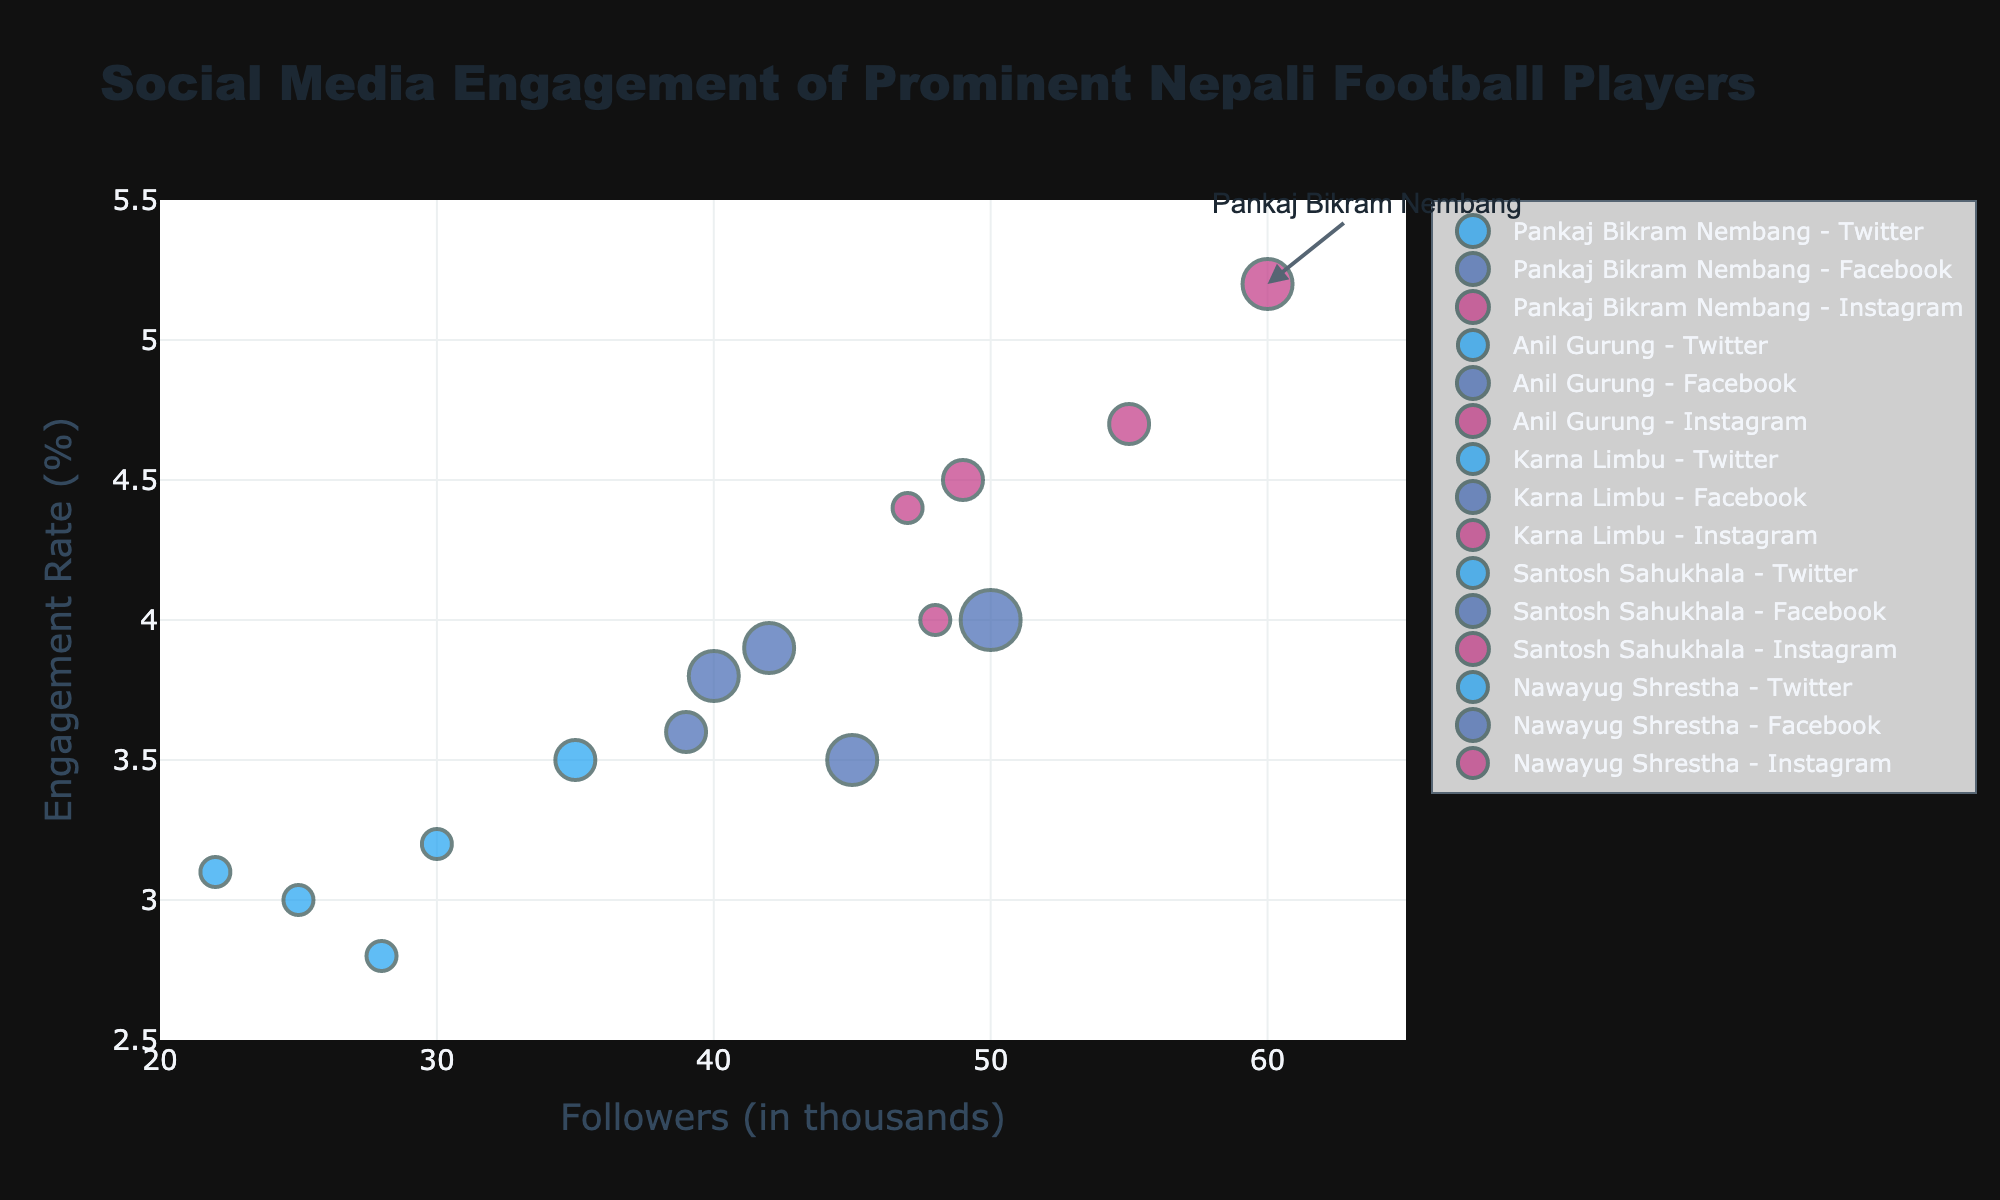what is the title of the chart? The title of the chart is displayed at the top center of the figure in a larger font size, making it easy to identify the central theme of the chart.
Answer: Social Media Engagement of Prominent Nepali Football Players How many players are shown in the bubble chart? The bubble chart includes distinct bubbles representing individual players across platforms. Each player's data can be identified by examining the hover information or legend. There are five players: Pankaj Bikram Nembang, Anil Gurung, Karna Limbu, Santosh Sahukhala, and Nawayug Shrestha.
Answer: Five Who has the highest engagement rate on Instagram? By examining the Y-axis values for Instagram's colored bubbles on the chart, one can identify the highest engagement rate. The hover information or legend confirms this, and the highest engagement rate on Instagram is 5.2% for Pankaj Bikram Nembang.
Answer: Pankaj Bikram Nembang What is the average number of posts per week for Anil Gurung on all platforms? To find the average, take the sum of posts per week on all platforms for Anil Gurung and divide by the number of platforms. He posts 3 times on Twitter, 5 times on Facebook, and 4 times on Instagram. Thus, (3 + 5 + 4) / 3 = 4.
Answer: 4 Compare the engagement rates of Pankaj Bikram Nembang and Anil Gurung on Facebook. Who has a higher rate and by how much? By looking at the Y-axis values associated with the Facebook bubbles for both players, Pankaj Bikram Nembang has an engagement rate of 4.0% while Anil Gurung has 3.5%. The difference is 4.0% - 3.5% = 0.5%.
Answer: Pankaj Bikram Nembang by 0.5% Which platform does Nawayug Shrestha have the least number of followers on, and how many followers does he have there? By examining the X-axis values associated with Nawayug Shrestha's bubbles, identify the platform with the smallest value. The least number of followers for Nawayug Shrestha is on Twitter, with 22k followers.
Answer: Twitter, 22k What is the total number of followers for Karna Limbu across all platforms? Sum up the follower counts for Karna Limbu across Twitter, Facebook, and Instagram. This is 25k + 40k + 48k = 113k.
Answer: 113k Which player posts the most per week on Twitter? By examining the size of the Twitter bubbles on the chart, which corresponds to the average posts per week, identify the largest bubble. Pankaj Bikram Nembang posts the most with 4 times per week.
Answer: Pankaj Bikram Nembang Among all platforms, which has the highest engagement rate for any player, and which player is it? By observing the maximum Y-axis value in the chart, the highest engagement rate across all platforms is for Instagram at 5.2%. This rate belongs to Pankaj Bikram Nembang.
Answer: Instagram, Pankaj Bikram Nembang 